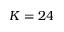<formula> <loc_0><loc_0><loc_500><loc_500>K = 2 4</formula> 